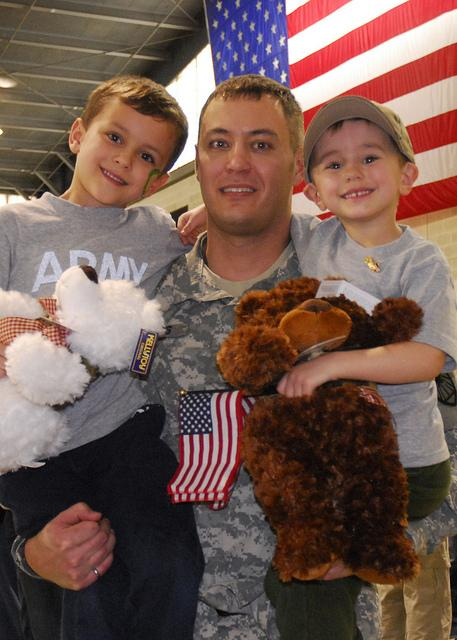What is the man's job? Please explain your reasoning. soldier. The man is wearing camouflage, one of his kids is wearing an army tee shirt, and the other is holding an american flag. the man is in the military. 